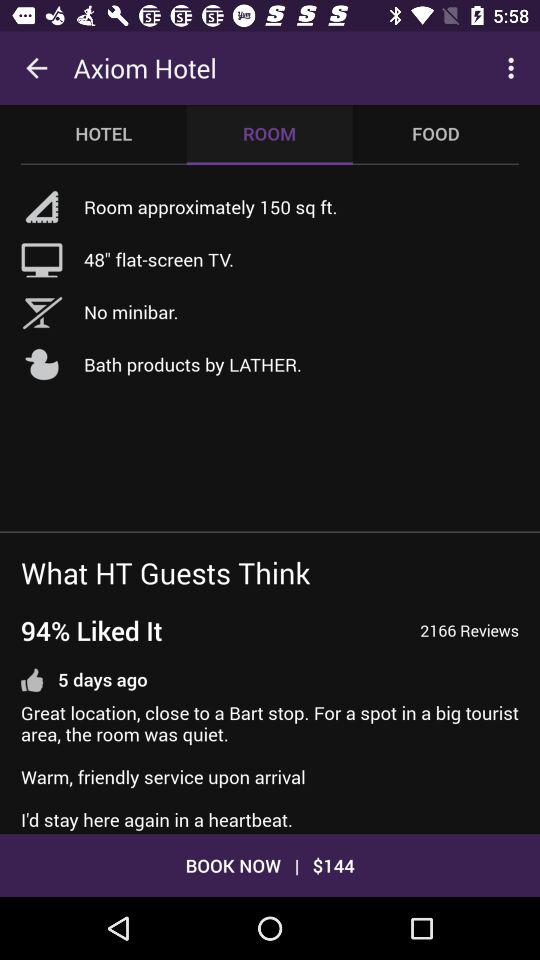How big is the room in square feet?
Answer the question using a single word or phrase. The room is 150 square feet 